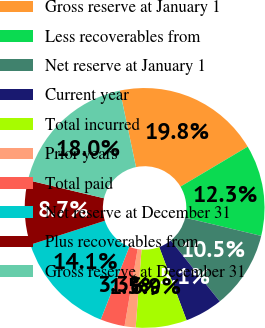Convert chart to OTSL. <chart><loc_0><loc_0><loc_500><loc_500><pie_chart><fcel>Gross reserve at January 1<fcel>Less recoverables from<fcel>Net reserve at January 1<fcel>Current year<fcel>Total incurred<fcel>Prior years<fcel>Total paid<fcel>Net reserve at December 31<fcel>Plus recoverables from<fcel>Gross reserve at December 31<nl><fcel>19.77%<fcel>12.28%<fcel>10.48%<fcel>5.08%<fcel>6.88%<fcel>1.49%<fcel>3.29%<fcel>14.08%<fcel>8.68%<fcel>17.97%<nl></chart> 